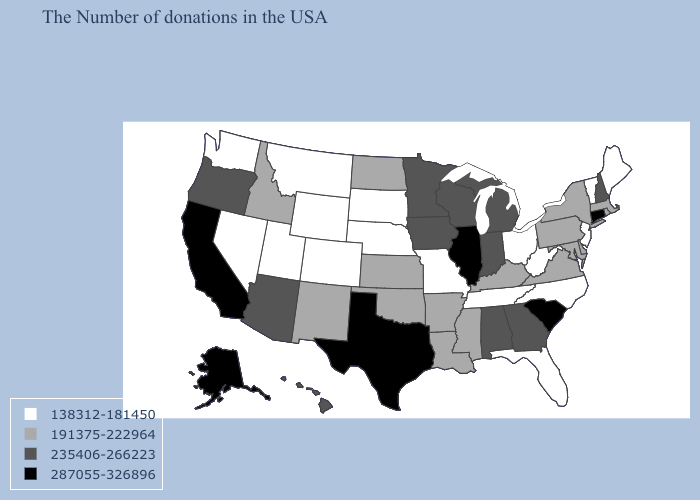What is the value of Oregon?
Keep it brief. 235406-266223. Name the states that have a value in the range 235406-266223?
Concise answer only. New Hampshire, Georgia, Michigan, Indiana, Alabama, Wisconsin, Minnesota, Iowa, Arizona, Oregon, Hawaii. Name the states that have a value in the range 138312-181450?
Write a very short answer. Maine, Vermont, New Jersey, North Carolina, West Virginia, Ohio, Florida, Tennessee, Missouri, Nebraska, South Dakota, Wyoming, Colorado, Utah, Montana, Nevada, Washington. Name the states that have a value in the range 191375-222964?
Be succinct. Massachusetts, Rhode Island, New York, Delaware, Maryland, Pennsylvania, Virginia, Kentucky, Mississippi, Louisiana, Arkansas, Kansas, Oklahoma, North Dakota, New Mexico, Idaho. What is the value of Illinois?
Be succinct. 287055-326896. Among the states that border Utah , which have the lowest value?
Quick response, please. Wyoming, Colorado, Nevada. Name the states that have a value in the range 287055-326896?
Write a very short answer. Connecticut, South Carolina, Illinois, Texas, California, Alaska. Name the states that have a value in the range 191375-222964?
Answer briefly. Massachusetts, Rhode Island, New York, Delaware, Maryland, Pennsylvania, Virginia, Kentucky, Mississippi, Louisiana, Arkansas, Kansas, Oklahoma, North Dakota, New Mexico, Idaho. What is the value of Alaska?
Give a very brief answer. 287055-326896. Does West Virginia have the lowest value in the USA?
Answer briefly. Yes. What is the lowest value in states that border Idaho?
Concise answer only. 138312-181450. How many symbols are there in the legend?
Concise answer only. 4. What is the value of New Mexico?
Quick response, please. 191375-222964. What is the lowest value in the USA?
Be succinct. 138312-181450. Does Alaska have the highest value in the USA?
Give a very brief answer. Yes. 